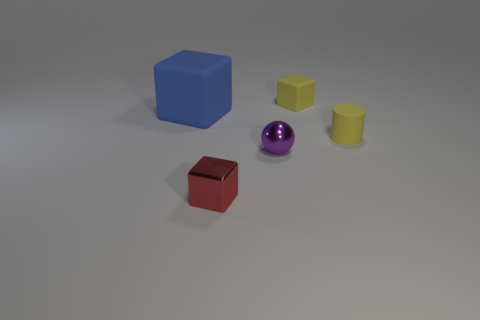What shape is the tiny rubber thing that is the same color as the small matte cylinder? The tiny rubber item that matches the color of the small matte cylinder is indeed a cube. It's a fascinating choice to use the same color for different shapes, challenging our perception and categorization of objects by color. 